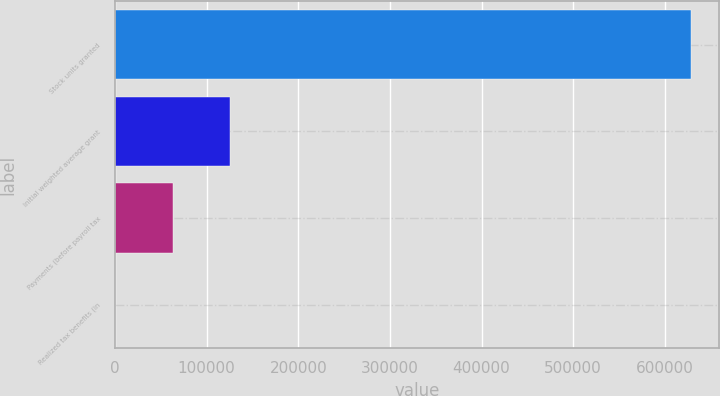Convert chart. <chart><loc_0><loc_0><loc_500><loc_500><bar_chart><fcel>Stock units granted<fcel>Initial weighted average grant<fcel>Payments (before payroll tax<fcel>Realized tax benefits (in<nl><fcel>628095<fcel>125627<fcel>62818.7<fcel>10.2<nl></chart> 